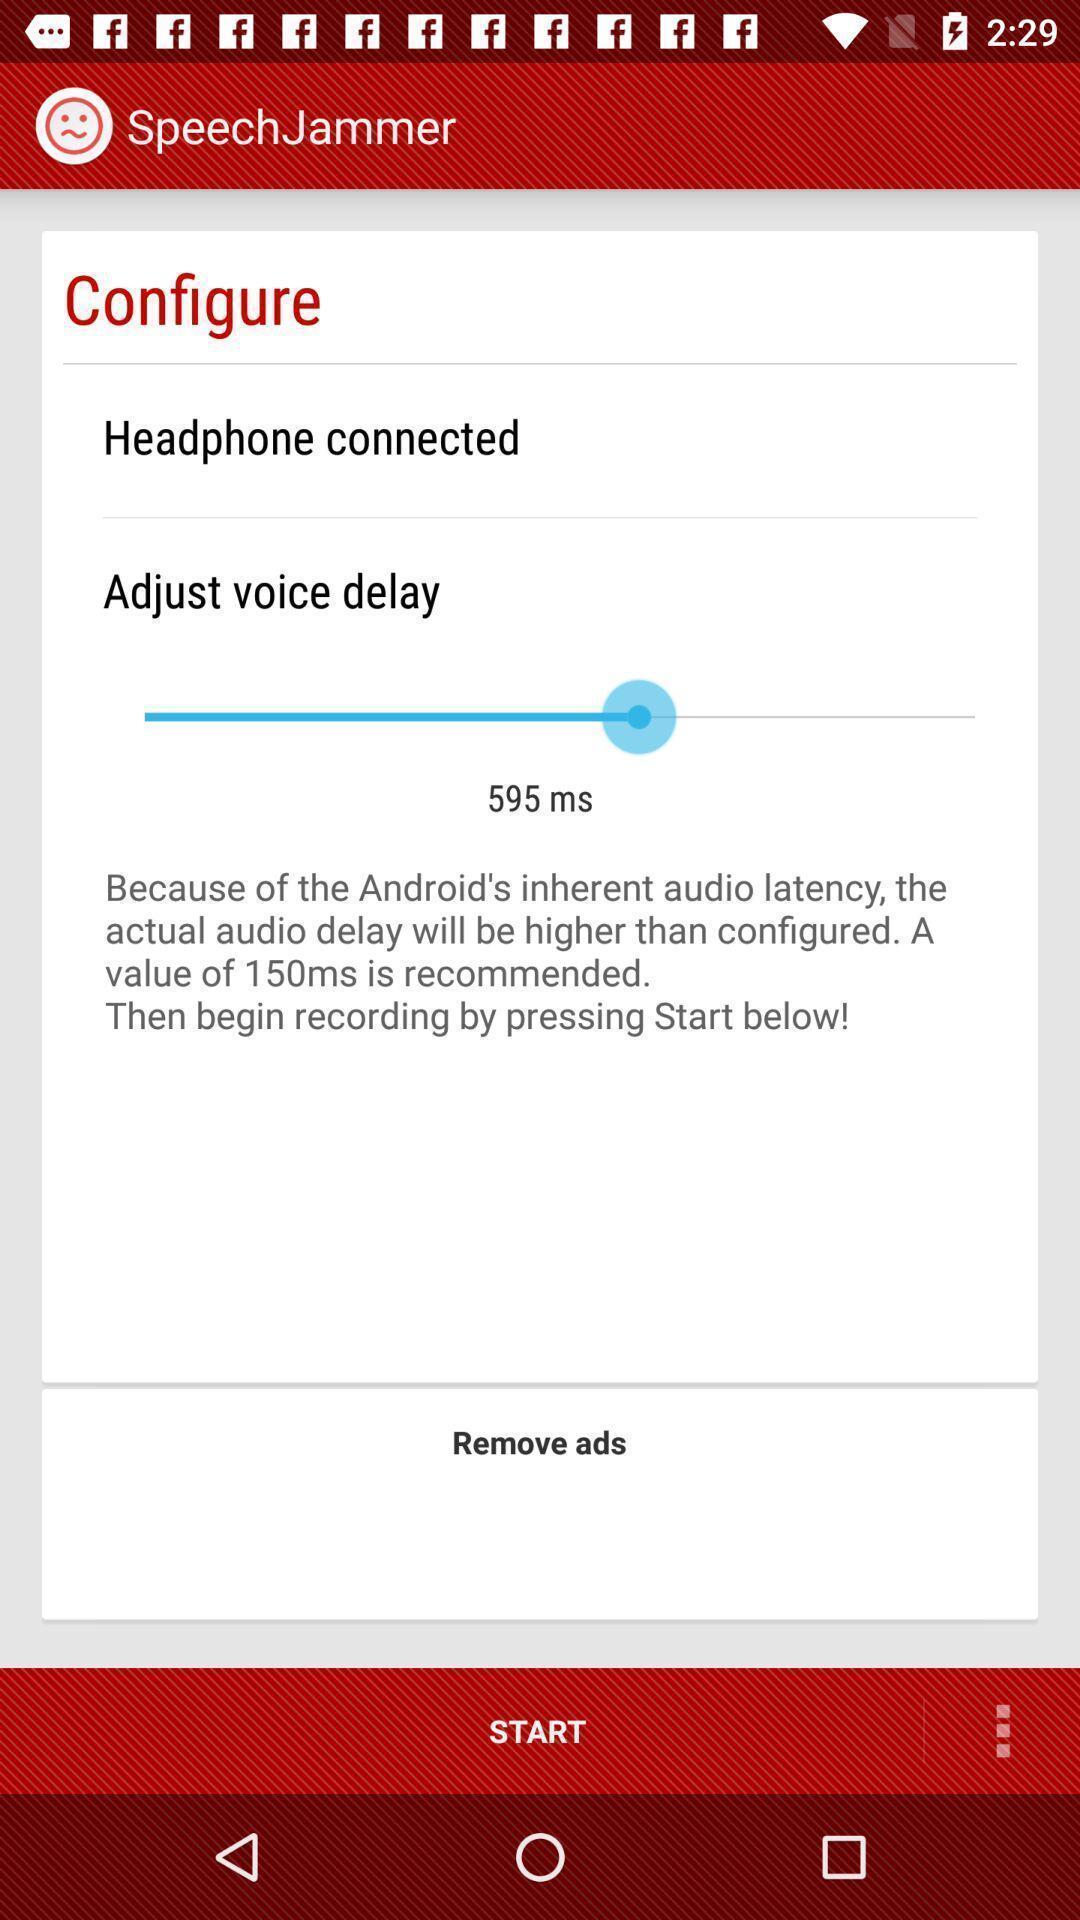Explain what's happening in this screen capture. Screen displaying configuration of headphones. 